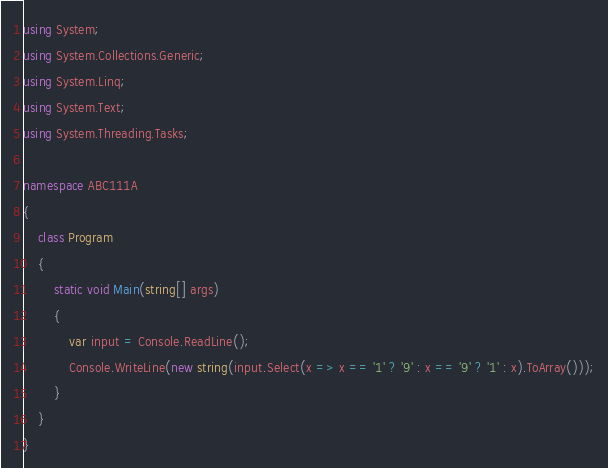Convert code to text. <code><loc_0><loc_0><loc_500><loc_500><_C#_>using System;
using System.Collections.Generic;
using System.Linq;
using System.Text;
using System.Threading.Tasks;

namespace ABC111A
{
    class Program
    {
        static void Main(string[] args)
        {
            var input = Console.ReadLine();
            Console.WriteLine(new string(input.Select(x => x == '1' ? '9' : x == '9' ? '1' : x).ToArray()));
        }
    }
}
</code> 